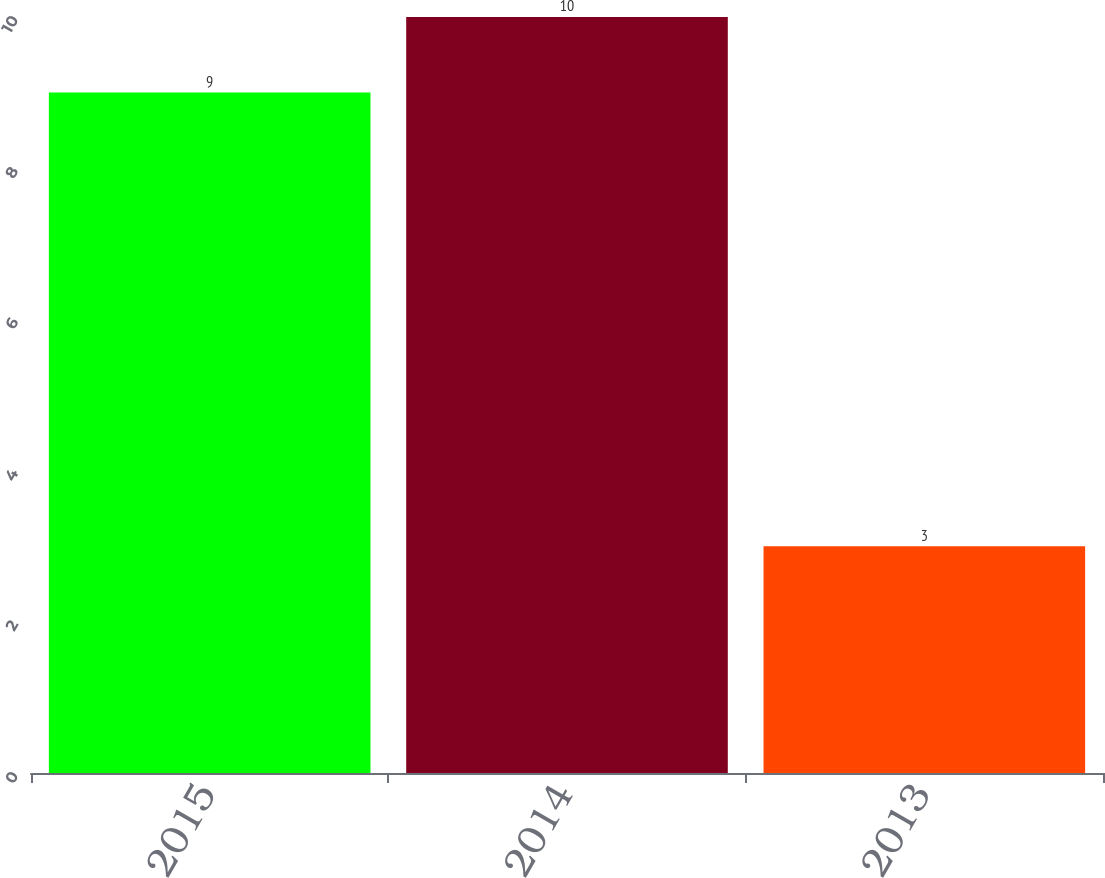<chart> <loc_0><loc_0><loc_500><loc_500><bar_chart><fcel>2015<fcel>2014<fcel>2013<nl><fcel>9<fcel>10<fcel>3<nl></chart> 